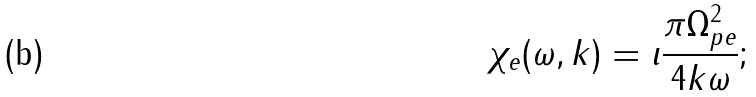Convert formula to latex. <formula><loc_0><loc_0><loc_500><loc_500>\chi _ { e } ( \omega , k ) = \imath \frac { \pi \Omega _ { p e } ^ { 2 } } { 4 k \omega } ;</formula> 